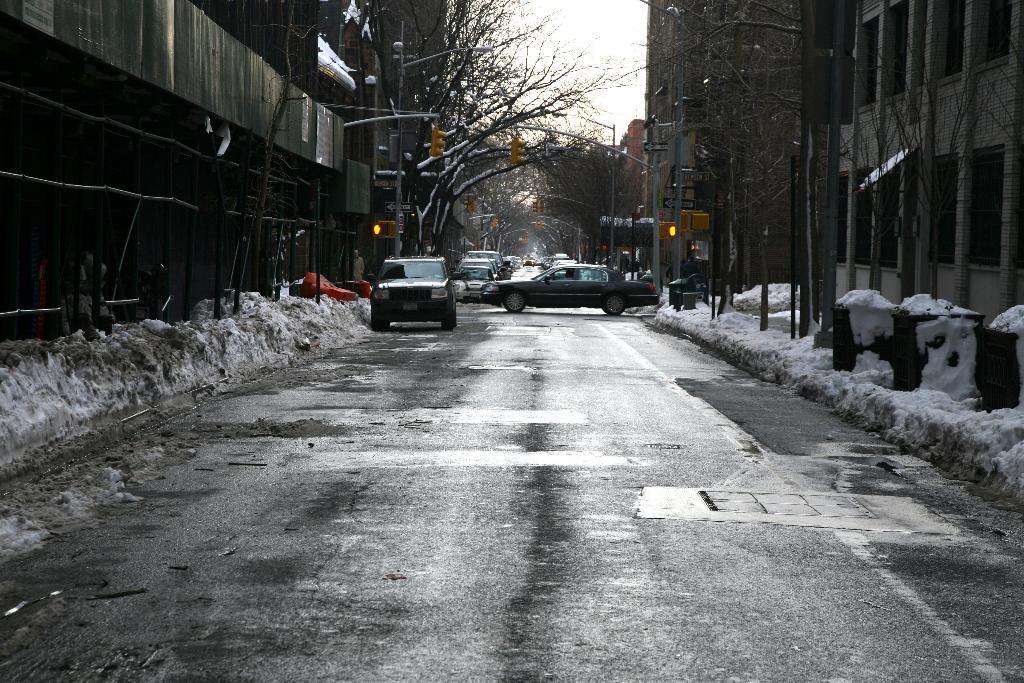Describe this image in one or two sentences. In the foreground of this image, there is a road to which snow, buildings, trees and poles are on the either side. In the background, there are trees, vehicles on the road, poles and the sky. 